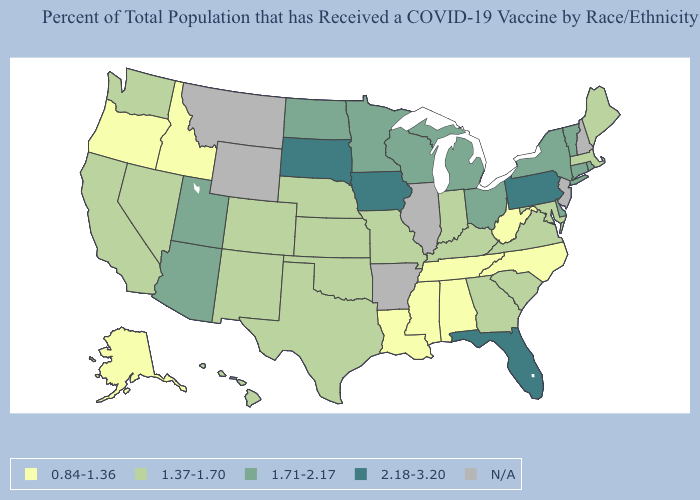What is the lowest value in the USA?
Give a very brief answer. 0.84-1.36. Among the states that border New Jersey , does Pennsylvania have the lowest value?
Write a very short answer. No. Among the states that border North Dakota , which have the lowest value?
Short answer required. Minnesota. What is the value of Maryland?
Answer briefly. 1.37-1.70. Among the states that border New York , does Pennsylvania have the lowest value?
Answer briefly. No. How many symbols are there in the legend?
Keep it brief. 5. Does Iowa have the lowest value in the USA?
Answer briefly. No. Name the states that have a value in the range 1.71-2.17?
Give a very brief answer. Arizona, Connecticut, Delaware, Michigan, Minnesota, New York, North Dakota, Ohio, Rhode Island, Utah, Vermont, Wisconsin. Among the states that border Idaho , does Oregon have the lowest value?
Concise answer only. Yes. Name the states that have a value in the range 0.84-1.36?
Answer briefly. Alabama, Alaska, Idaho, Louisiana, Mississippi, North Carolina, Oregon, Tennessee, West Virginia. Among the states that border Indiana , does Kentucky have the highest value?
Short answer required. No. What is the value of Texas?
Keep it brief. 1.37-1.70. Does Nevada have the lowest value in the West?
Short answer required. No. What is the lowest value in the USA?
Answer briefly. 0.84-1.36. 